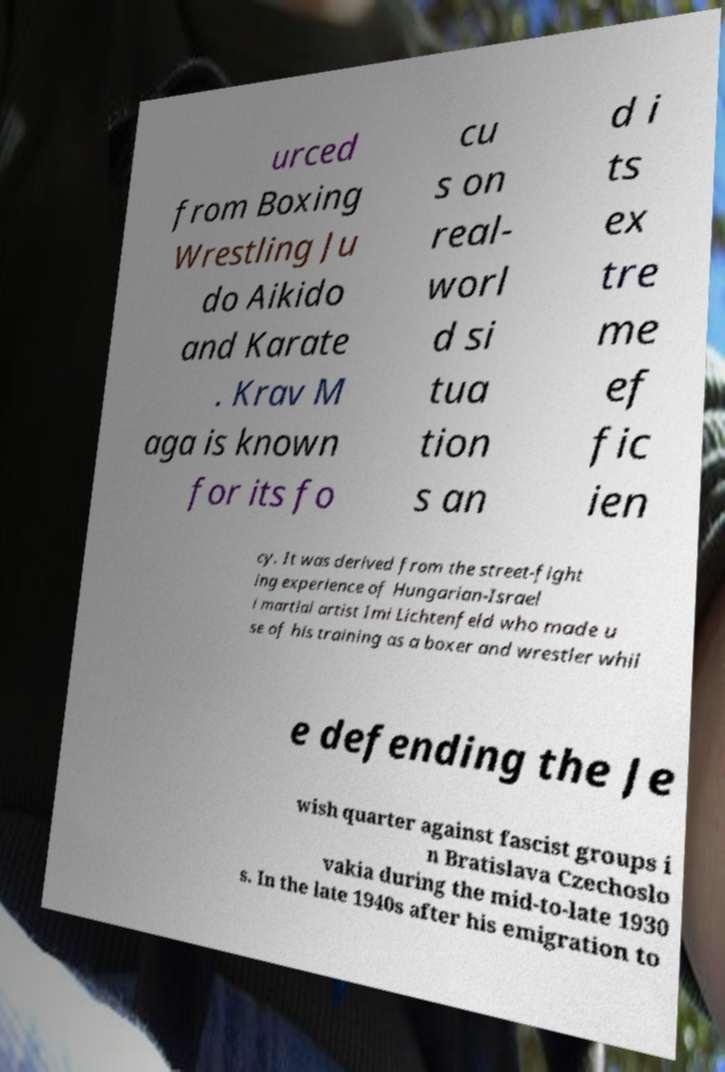For documentation purposes, I need the text within this image transcribed. Could you provide that? urced from Boxing Wrestling Ju do Aikido and Karate . Krav M aga is known for its fo cu s on real- worl d si tua tion s an d i ts ex tre me ef fic ien cy. It was derived from the street-fight ing experience of Hungarian-Israel i martial artist Imi Lichtenfeld who made u se of his training as a boxer and wrestler whil e defending the Je wish quarter against fascist groups i n Bratislava Czechoslo vakia during the mid-to-late 1930 s. In the late 1940s after his emigration to 